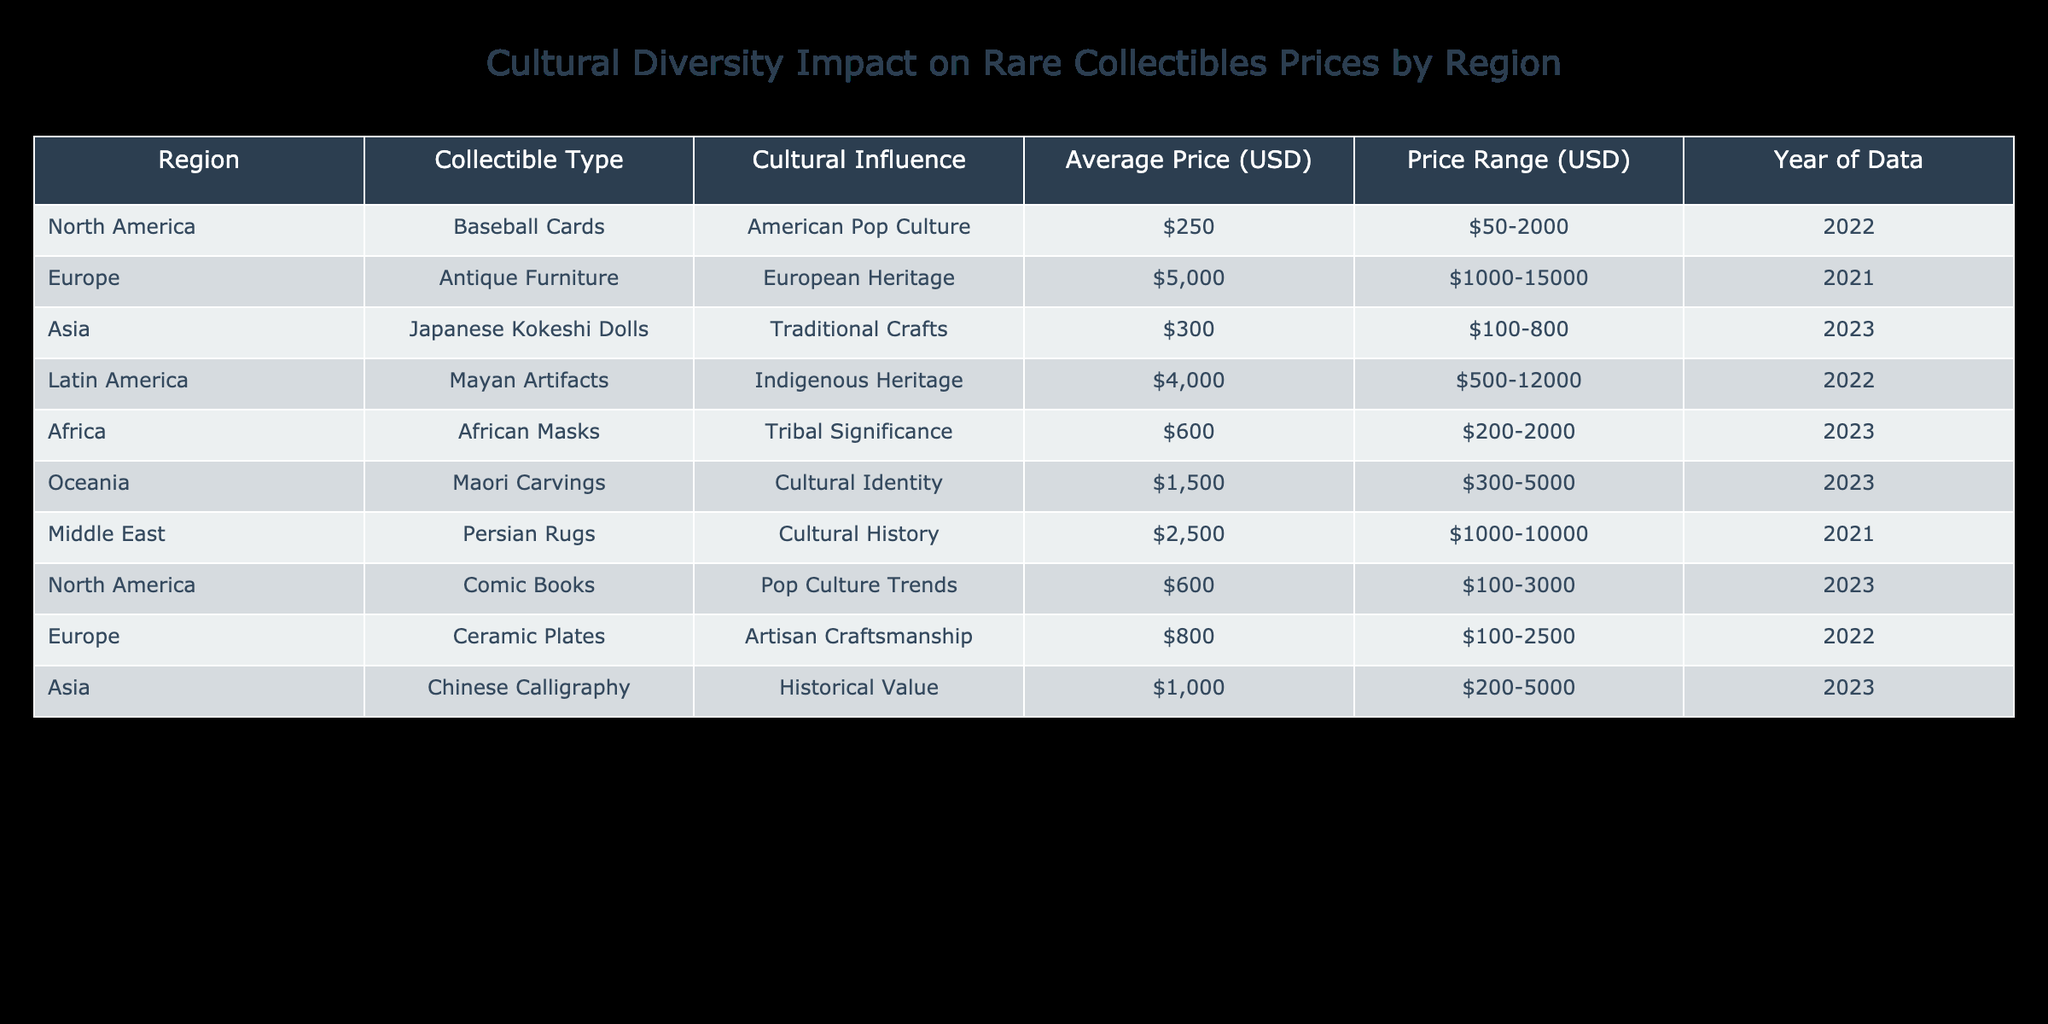What is the average price of collectibles in North America? In the table, the average price for North America is listed under the column "Average Price (USD)" for both types of collectibles: Baseball Cards at 250 and Comic Books at 600. To find the average, add these two prices: 250 + 600 = 850, and then divide by 2, as there are two items, which gives 850 / 2 = 425.
Answer: 425 Which collectible from Asia has the highest average price? The table presents two collectibles from Asia: Japanese Kokeshi Dolls with an average price of 300 and Chinese Calligraphy with an average price of 1000. The highest average price among these is for Chinese Calligraphy.
Answer: Chinese Calligraphy True or False: Antiquities in Europe have a wider price range than collectibles in Africa. In the table, European antique furniture has a price range of 1000 to 15000, while African masks have a range of 200 to 2000. The price range for Europe is much wider (14000) compared to Africa (1800). Therefore, this statement is true.
Answer: True What is the combined average price of Mayan Artifacts and Maori Carvings? The average price of Mayan Artifacts is 4000 and the average price of Maori Carvings is 1500. To find the combined average price, first add the two average prices: 4000 + 1500 = 5500. Since there are two items, divide by 2: 5500 / 2 = 2750.
Answer: 2750 Which region has the lowest average priced collectible, and what is the price? According to the table, Africa has African Masks priced at an average of 600, and Asia has Japanese Kokeshi Dolls at 300. The lowest average price is therefore 300 for Japanese Kokeshi Dolls from Asia.
Answer: Asia, 300 